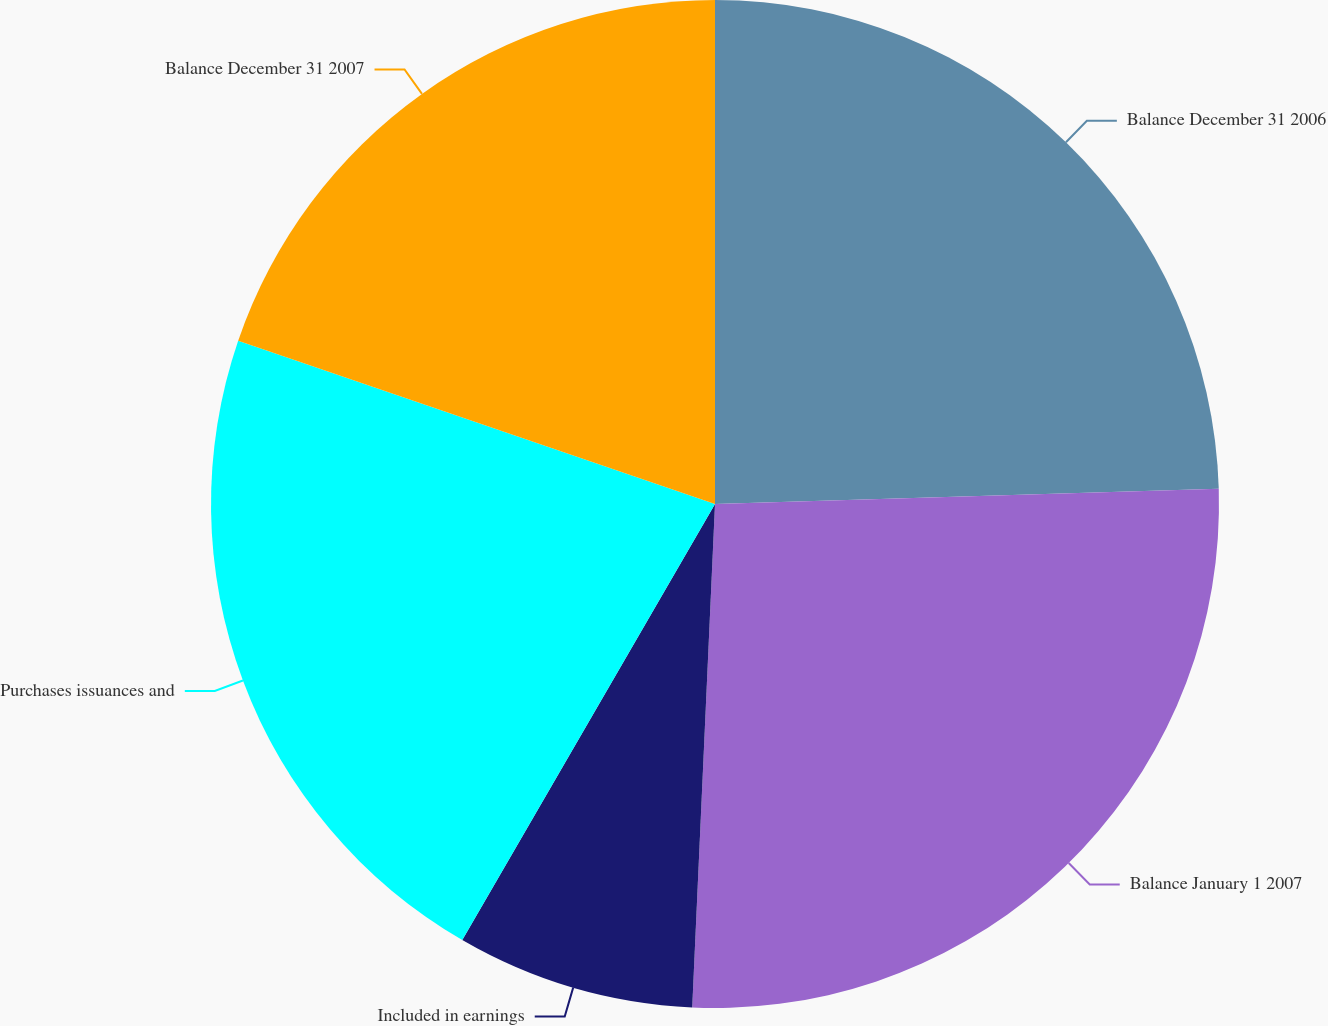Convert chart. <chart><loc_0><loc_0><loc_500><loc_500><pie_chart><fcel>Balance December 31 2006<fcel>Balance January 1 2007<fcel>Included in earnings<fcel>Purchases issuances and<fcel>Balance December 31 2007<nl><fcel>24.52%<fcel>26.2%<fcel>7.64%<fcel>21.89%<fcel>19.75%<nl></chart> 